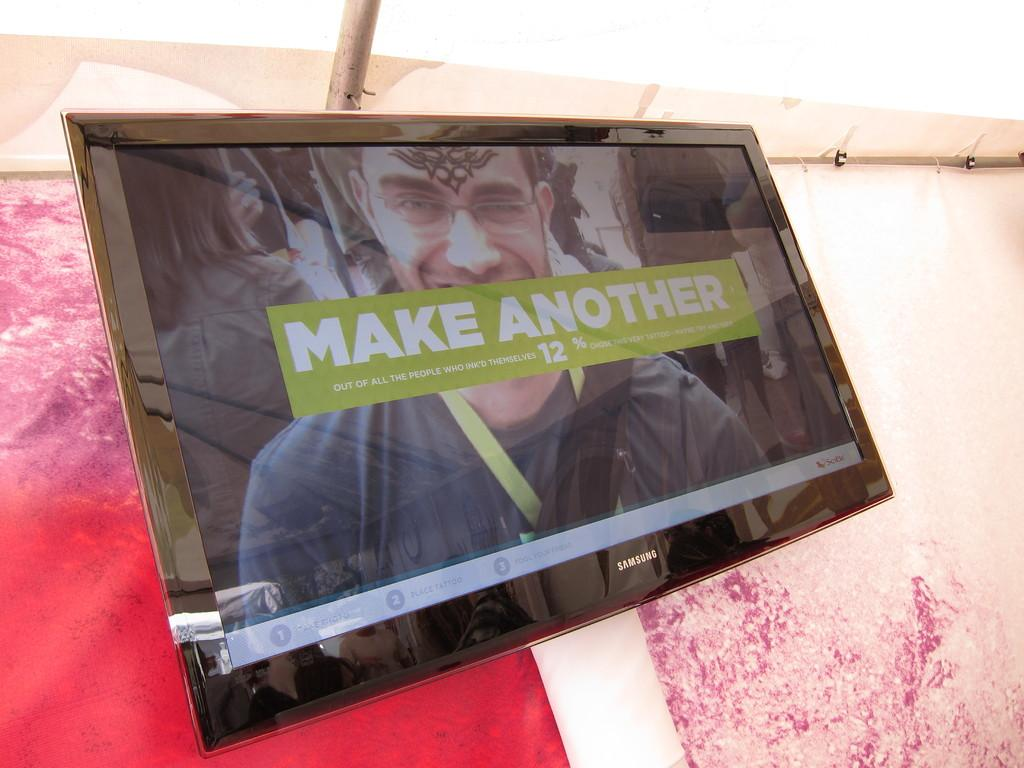What type of electronic device is present in the image? There is a television in the image. Where is the television located in the image? The television is mounted on a wall. What is displayed on the television screen? The television screen displays text and an image of a person. What type of door can be seen on the television screen? There is no door present on the television screen; it displays text and an image of a person. What color is the thread used to sew the thumb in the image? There is no thread or thumb present in the image; it features a television mounted on a wall with a screen displaying text and an image of a person. 